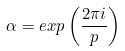Convert formula to latex. <formula><loc_0><loc_0><loc_500><loc_500>\alpha = e x p \left ( \frac { 2 \pi i } { p } \right )</formula> 